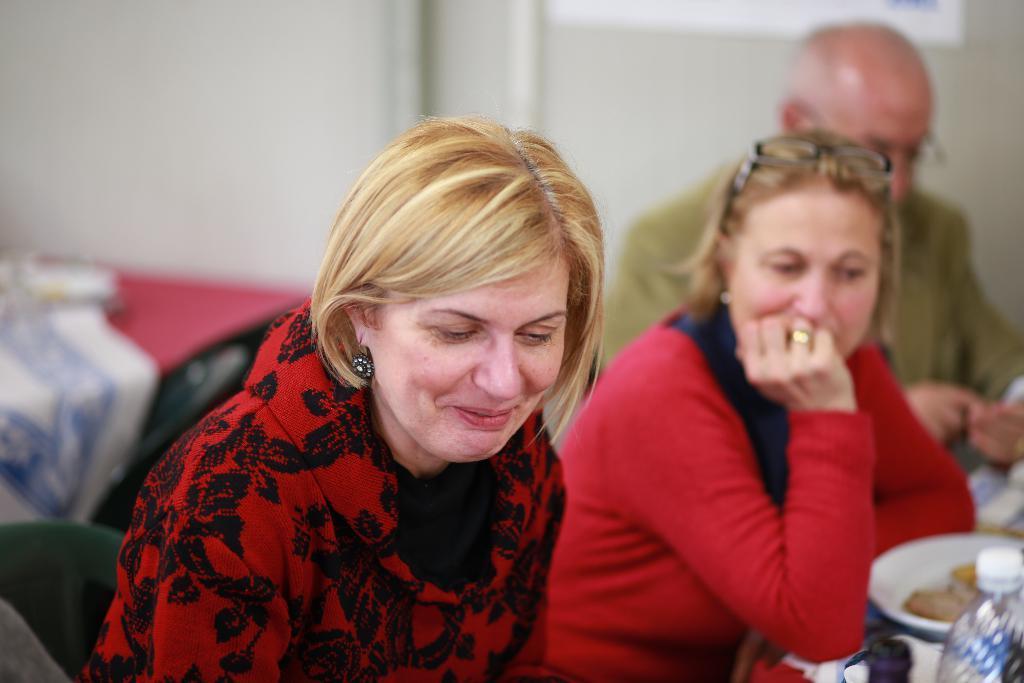In one or two sentences, can you explain what this image depicts? In this picture I can observe three members. Two of them are women and one of them is a man. On the right side I can observe a plate and water bottle. In the background there is a wall. 